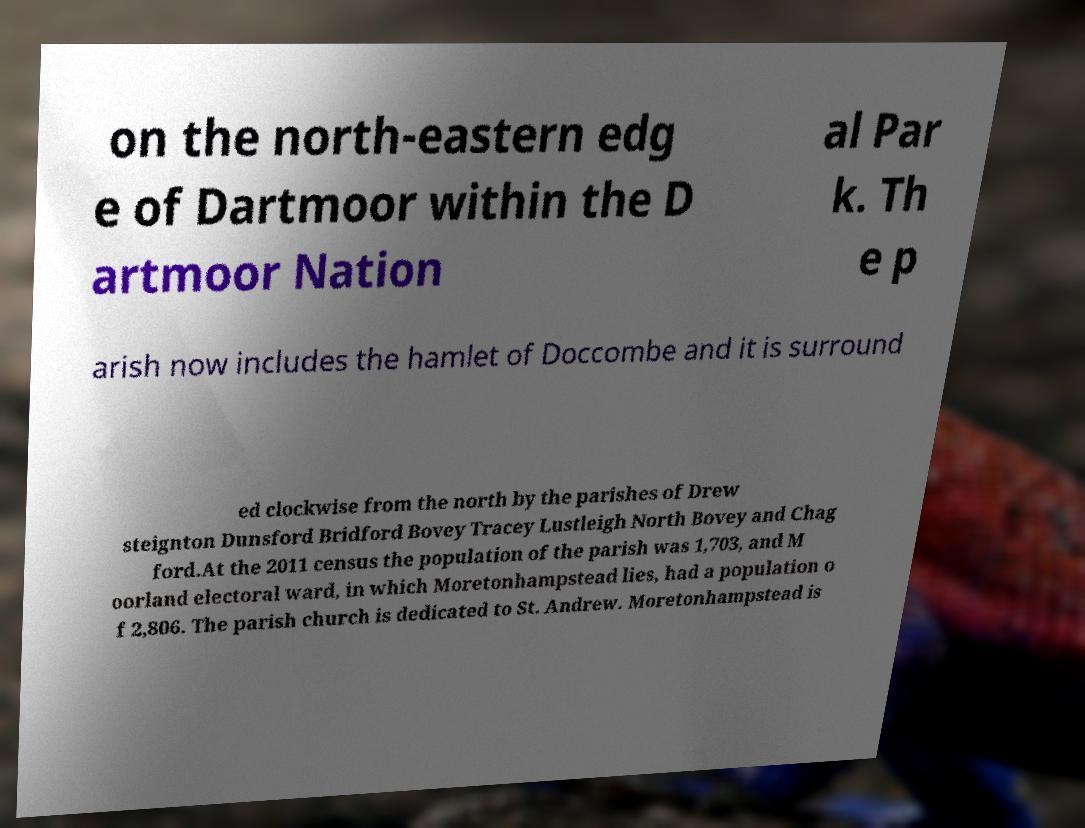There's text embedded in this image that I need extracted. Can you transcribe it verbatim? on the north-eastern edg e of Dartmoor within the D artmoor Nation al Par k. Th e p arish now includes the hamlet of Doccombe and it is surround ed clockwise from the north by the parishes of Drew steignton Dunsford Bridford Bovey Tracey Lustleigh North Bovey and Chag ford.At the 2011 census the population of the parish was 1,703, and M oorland electoral ward, in which Moretonhampstead lies, had a population o f 2,806. The parish church is dedicated to St. Andrew. Moretonhampstead is 